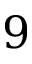<formula> <loc_0><loc_0><loc_500><loc_500>9</formula> 